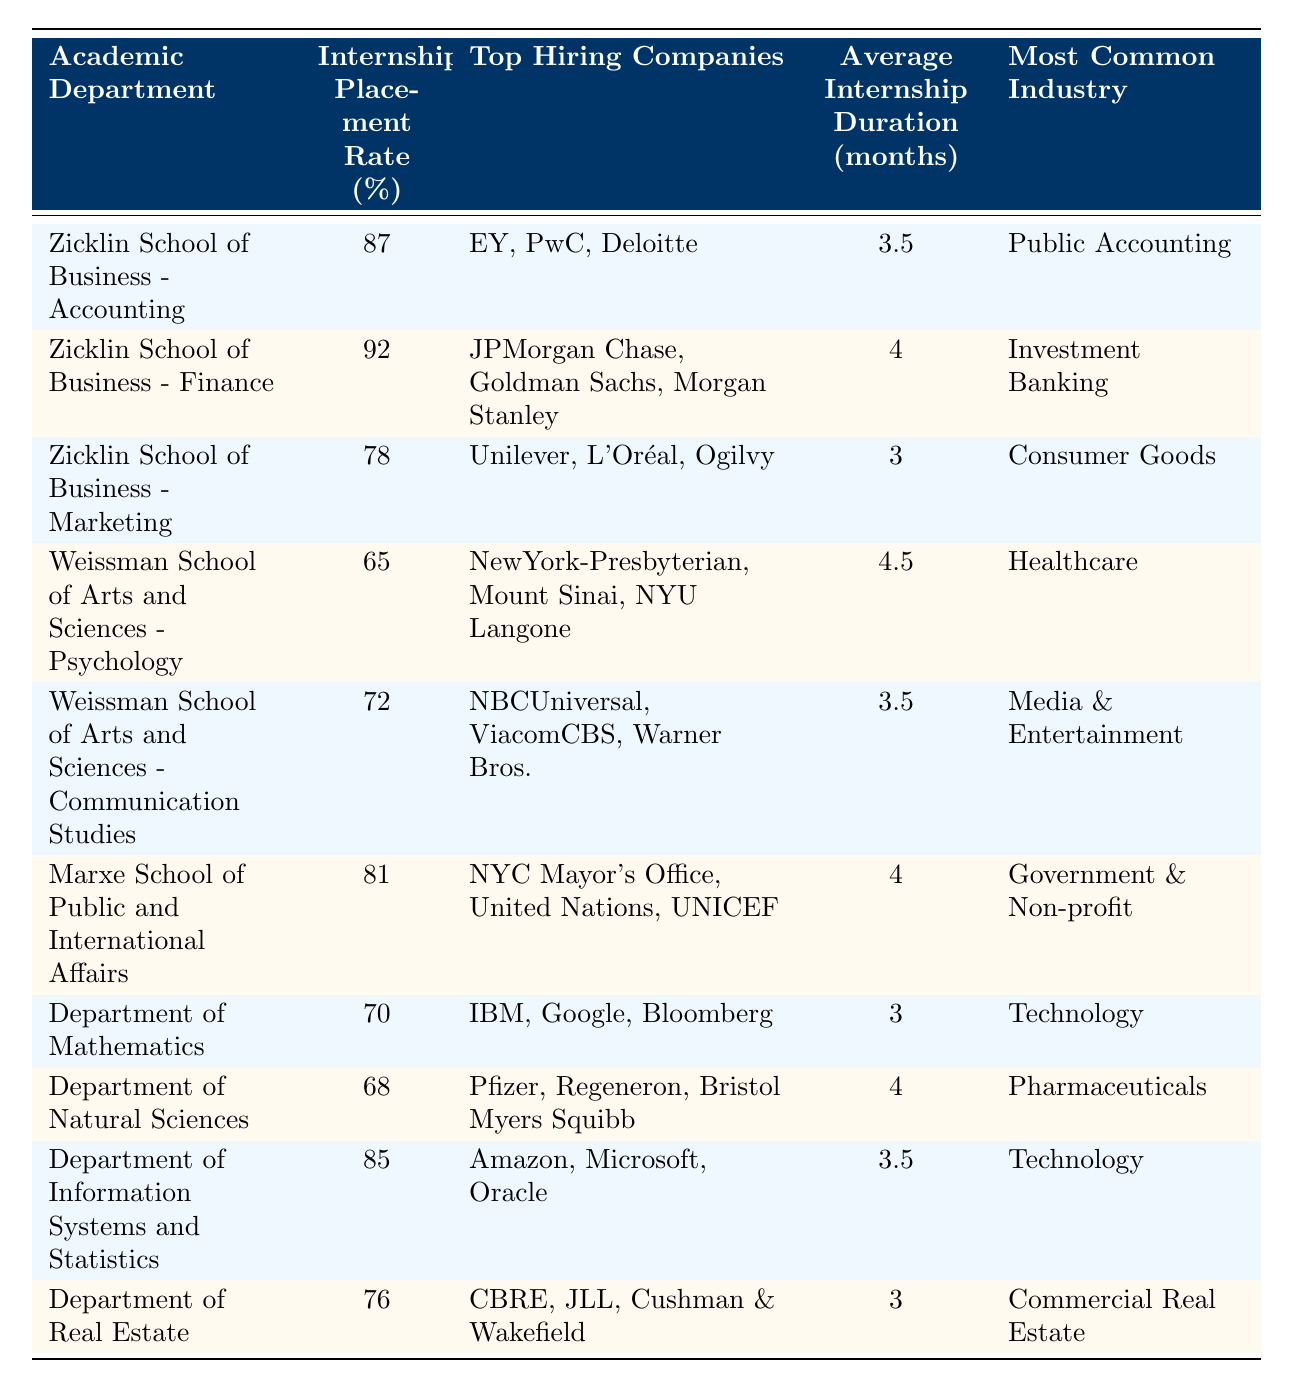What is the internship placement rate for the Zicklin School of Business - Finance? The specific rate for the Zicklin School of Business - Finance is listed in the table, showing 92%.
Answer: 92% Which academic department has the lowest internship placement rate? By comparing the values in the "Internship Placement Rate (%)" column, Weissman School of Arts and Sciences - Psychology has the lowest rate at 65%.
Answer: Weissman School of Arts and Sciences - Psychology What is the average internship duration for students in the Department of Information Systems and Statistics? The average internship duration given in the table for this department is 3.5 months.
Answer: 3.5 months How many top hiring companies are listed for the Zicklin School of Business - Accounting? The table lists three companies for this department (EY, PwC, Deloitte).
Answer: 3 What is the difference in internship placement rates between the Zicklin School of Business - Marketing and the Marxe School of Public and International Affairs? The placement rate for the Zicklin School of Business - Marketing is 78% and for the Marxe School is 81%. The difference is 81% - 78% = 3%.
Answer: 3% Which department has the highest average internship duration and what is that duration? By checking the "Average Internship Duration (months)" column, Weissman School of Arts and Sciences - Psychology has the highest duration of 4.5 months.
Answer: Weissman School of Arts and Sciences - Psychology, 4.5 months How many departments have an internship placement rate higher than 80%? The departments with rates higher than 80% are Zicklin School of Business - Accounting (87%), Zicklin School of Business - Finance (92%) and Department of Information Systems and Statistics (85%). This totals to three departments.
Answer: 3 Is it true that all departments in the Zicklin School of Business have an internship placement rate above 75%? Comparing the rates, both Accounting (87%) and Finance (92%) are above 75%, but Marketing (78%) is also above 75%. Therefore, it is true.
Answer: Yes What is the most common industry for students in the Department of Natural Sciences? The table specifies the most common industry for the Department of Natural Sciences is Pharmaceuticals.
Answer: Pharmaceuticals If we consider the top hiring companies, which sector appears most frequently among the various departments? By analyzing the "Top Hiring Companies" column, Technology companies appear most frequently (Department of Mathematics and Information Systems and Statistics), therefore that sector is the most common.
Answer: Technology 